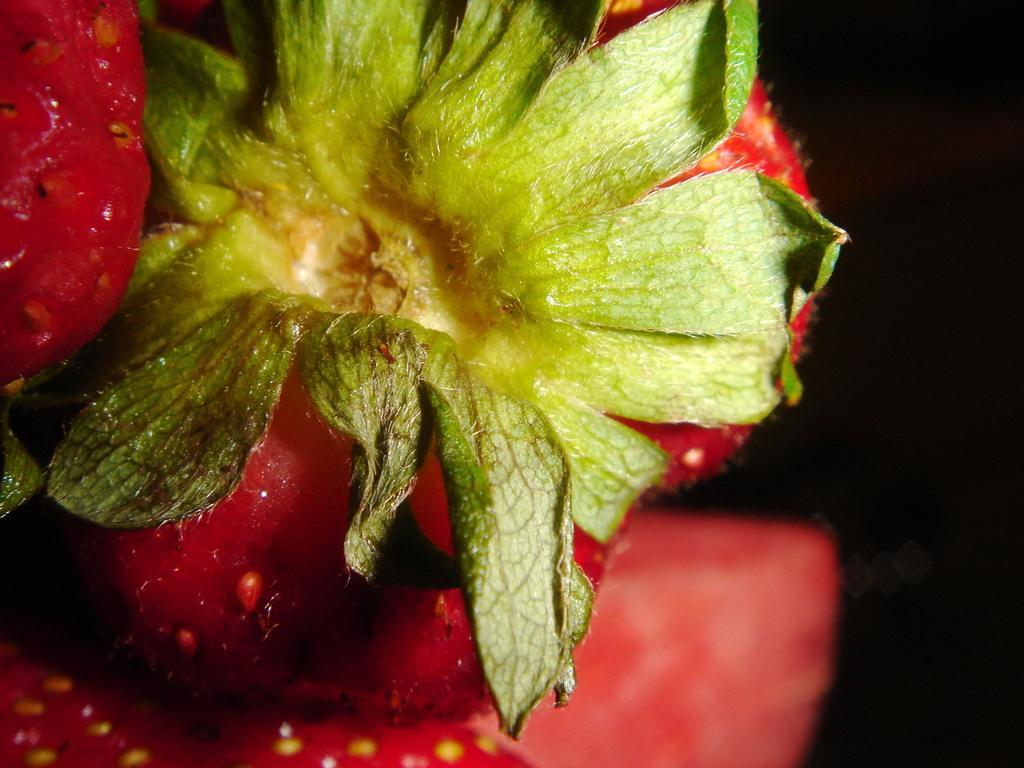Can you describe this image briefly? On the left side of this image I can see few strawberries along with the leaves. The background is in black color. 